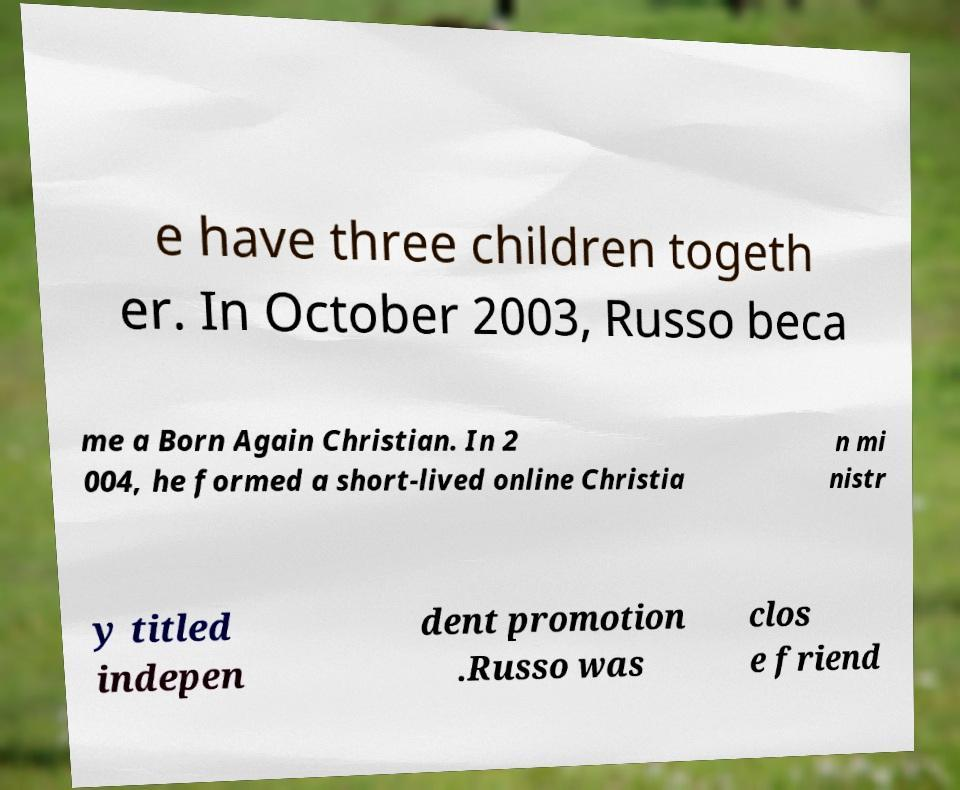Can you read and provide the text displayed in the image?This photo seems to have some interesting text. Can you extract and type it out for me? e have three children togeth er. In October 2003, Russo beca me a Born Again Christian. In 2 004, he formed a short-lived online Christia n mi nistr y titled indepen dent promotion .Russo was clos e friend 